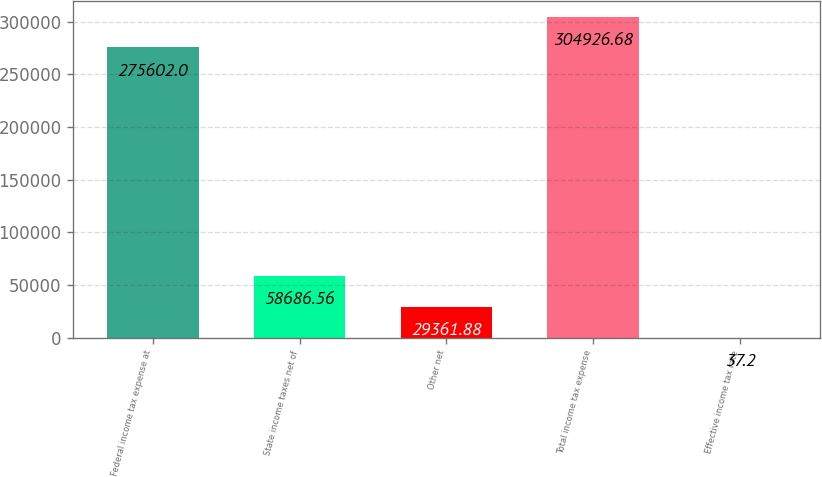<chart> <loc_0><loc_0><loc_500><loc_500><bar_chart><fcel>Federal income tax expense at<fcel>State income taxes net of<fcel>Other net<fcel>Total income tax expense<fcel>Effective income tax rate<nl><fcel>275602<fcel>58686.6<fcel>29361.9<fcel>304927<fcel>37.2<nl></chart> 